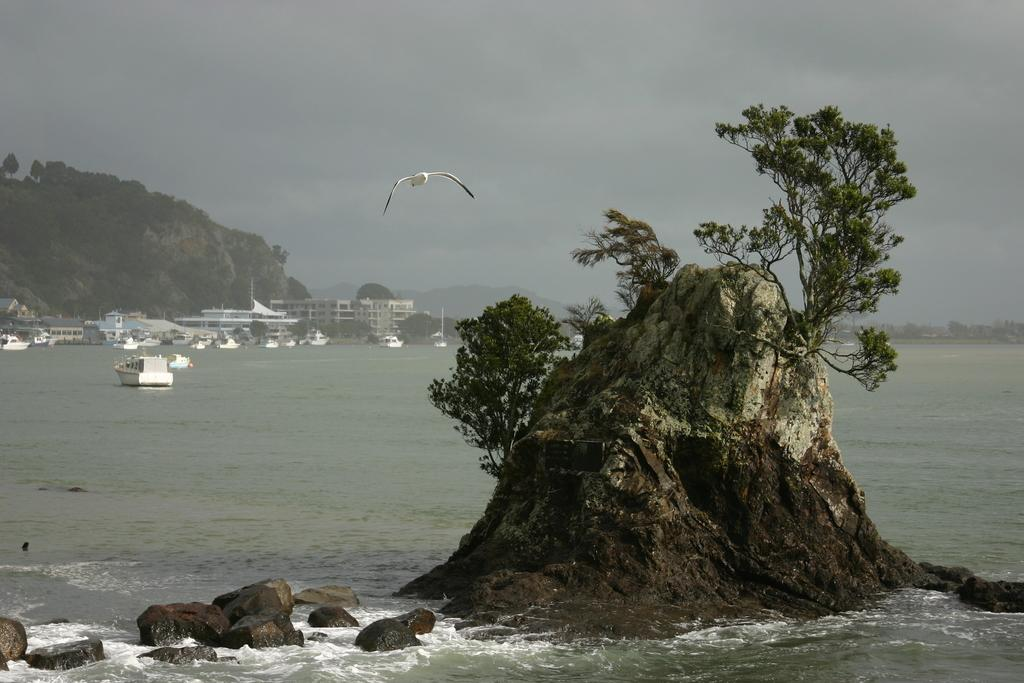What is the main subject of the image? The main subject of the image is a bird flying. Can you describe the landscape in the image? There is a rock with trees on the water, and there are mountains in the image. What other objects can be seen in the image? There are ships, buildings, and trees visible in the image. What part of the natural environment is visible in the image? The sky is visible in the image. How many sisters are sitting in the car in the image? There is no car or sisters present in the image. What type of pies are being served at the picnic in the image? There is no picnic or pies present in the image. 